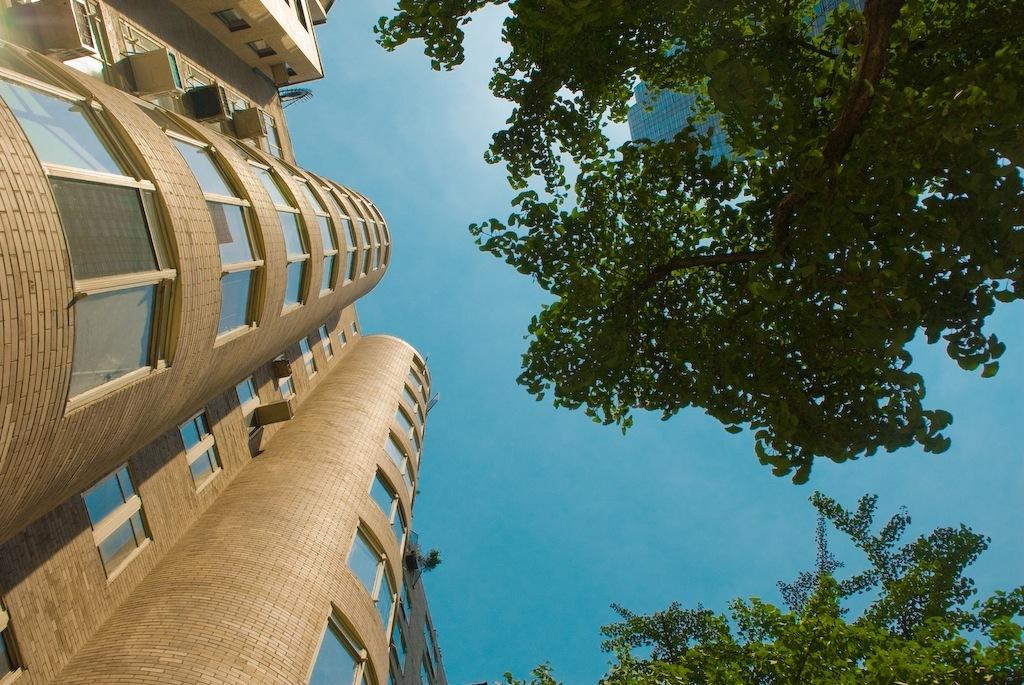Please provide a concise description of this image. In this image I can see a building and number of windows. I can also see trees, the and one more building in background. 